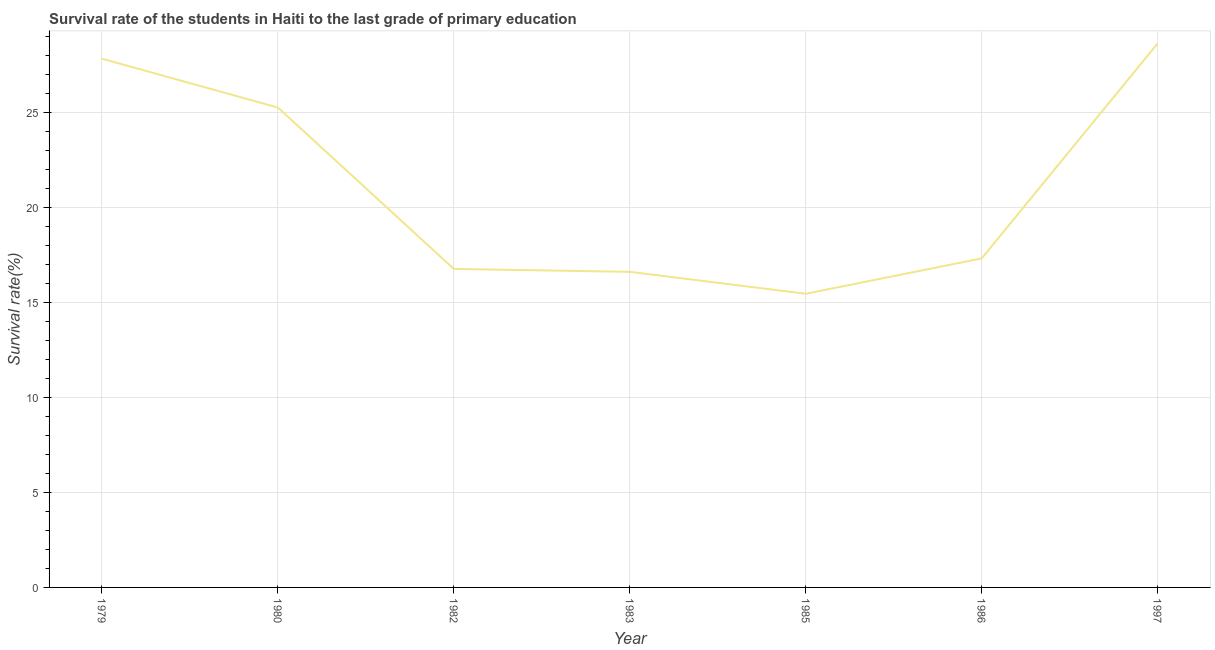What is the survival rate in primary education in 1997?
Offer a very short reply. 28.66. Across all years, what is the maximum survival rate in primary education?
Ensure brevity in your answer.  28.66. Across all years, what is the minimum survival rate in primary education?
Offer a terse response. 15.47. In which year was the survival rate in primary education maximum?
Your answer should be very brief. 1997. What is the sum of the survival rate in primary education?
Ensure brevity in your answer.  147.99. What is the difference between the survival rate in primary education in 1979 and 1985?
Ensure brevity in your answer.  12.38. What is the average survival rate in primary education per year?
Your answer should be very brief. 21.14. What is the median survival rate in primary education?
Offer a very short reply. 17.33. Do a majority of the years between 1997 and 1985 (inclusive) have survival rate in primary education greater than 5 %?
Offer a very short reply. No. What is the ratio of the survival rate in primary education in 1983 to that in 1997?
Your response must be concise. 0.58. What is the difference between the highest and the second highest survival rate in primary education?
Your response must be concise. 0.81. What is the difference between the highest and the lowest survival rate in primary education?
Provide a succinct answer. 13.19. How many lines are there?
Your answer should be very brief. 1. What is the difference between two consecutive major ticks on the Y-axis?
Offer a terse response. 5. Are the values on the major ticks of Y-axis written in scientific E-notation?
Provide a short and direct response. No. What is the title of the graph?
Your response must be concise. Survival rate of the students in Haiti to the last grade of primary education. What is the label or title of the X-axis?
Keep it short and to the point. Year. What is the label or title of the Y-axis?
Keep it short and to the point. Survival rate(%). What is the Survival rate(%) in 1979?
Your answer should be very brief. 27.85. What is the Survival rate(%) of 1980?
Give a very brief answer. 25.28. What is the Survival rate(%) in 1982?
Give a very brief answer. 16.78. What is the Survival rate(%) in 1983?
Provide a succinct answer. 16.62. What is the Survival rate(%) in 1985?
Provide a succinct answer. 15.47. What is the Survival rate(%) of 1986?
Your response must be concise. 17.33. What is the Survival rate(%) of 1997?
Your answer should be very brief. 28.66. What is the difference between the Survival rate(%) in 1979 and 1980?
Provide a short and direct response. 2.57. What is the difference between the Survival rate(%) in 1979 and 1982?
Ensure brevity in your answer.  11.07. What is the difference between the Survival rate(%) in 1979 and 1983?
Your answer should be very brief. 11.23. What is the difference between the Survival rate(%) in 1979 and 1985?
Provide a short and direct response. 12.38. What is the difference between the Survival rate(%) in 1979 and 1986?
Ensure brevity in your answer.  10.52. What is the difference between the Survival rate(%) in 1979 and 1997?
Keep it short and to the point. -0.81. What is the difference between the Survival rate(%) in 1980 and 1982?
Ensure brevity in your answer.  8.5. What is the difference between the Survival rate(%) in 1980 and 1983?
Make the answer very short. 8.65. What is the difference between the Survival rate(%) in 1980 and 1985?
Provide a succinct answer. 9.81. What is the difference between the Survival rate(%) in 1980 and 1986?
Give a very brief answer. 7.95. What is the difference between the Survival rate(%) in 1980 and 1997?
Offer a very short reply. -3.38. What is the difference between the Survival rate(%) in 1982 and 1983?
Offer a very short reply. 0.15. What is the difference between the Survival rate(%) in 1982 and 1985?
Offer a terse response. 1.31. What is the difference between the Survival rate(%) in 1982 and 1986?
Offer a terse response. -0.56. What is the difference between the Survival rate(%) in 1982 and 1997?
Make the answer very short. -11.88. What is the difference between the Survival rate(%) in 1983 and 1985?
Your response must be concise. 1.16. What is the difference between the Survival rate(%) in 1983 and 1986?
Your answer should be very brief. -0.71. What is the difference between the Survival rate(%) in 1983 and 1997?
Offer a terse response. -12.04. What is the difference between the Survival rate(%) in 1985 and 1986?
Make the answer very short. -1.86. What is the difference between the Survival rate(%) in 1985 and 1997?
Offer a very short reply. -13.19. What is the difference between the Survival rate(%) in 1986 and 1997?
Your response must be concise. -11.33. What is the ratio of the Survival rate(%) in 1979 to that in 1980?
Provide a short and direct response. 1.1. What is the ratio of the Survival rate(%) in 1979 to that in 1982?
Offer a very short reply. 1.66. What is the ratio of the Survival rate(%) in 1979 to that in 1983?
Offer a terse response. 1.68. What is the ratio of the Survival rate(%) in 1979 to that in 1985?
Provide a succinct answer. 1.8. What is the ratio of the Survival rate(%) in 1979 to that in 1986?
Your response must be concise. 1.61. What is the ratio of the Survival rate(%) in 1979 to that in 1997?
Offer a very short reply. 0.97. What is the ratio of the Survival rate(%) in 1980 to that in 1982?
Provide a short and direct response. 1.51. What is the ratio of the Survival rate(%) in 1980 to that in 1983?
Your response must be concise. 1.52. What is the ratio of the Survival rate(%) in 1980 to that in 1985?
Give a very brief answer. 1.63. What is the ratio of the Survival rate(%) in 1980 to that in 1986?
Your response must be concise. 1.46. What is the ratio of the Survival rate(%) in 1980 to that in 1997?
Your answer should be compact. 0.88. What is the ratio of the Survival rate(%) in 1982 to that in 1985?
Your answer should be very brief. 1.08. What is the ratio of the Survival rate(%) in 1982 to that in 1986?
Offer a terse response. 0.97. What is the ratio of the Survival rate(%) in 1982 to that in 1997?
Provide a short and direct response. 0.58. What is the ratio of the Survival rate(%) in 1983 to that in 1985?
Your answer should be compact. 1.07. What is the ratio of the Survival rate(%) in 1983 to that in 1997?
Provide a succinct answer. 0.58. What is the ratio of the Survival rate(%) in 1985 to that in 1986?
Ensure brevity in your answer.  0.89. What is the ratio of the Survival rate(%) in 1985 to that in 1997?
Offer a terse response. 0.54. What is the ratio of the Survival rate(%) in 1986 to that in 1997?
Offer a terse response. 0.6. 